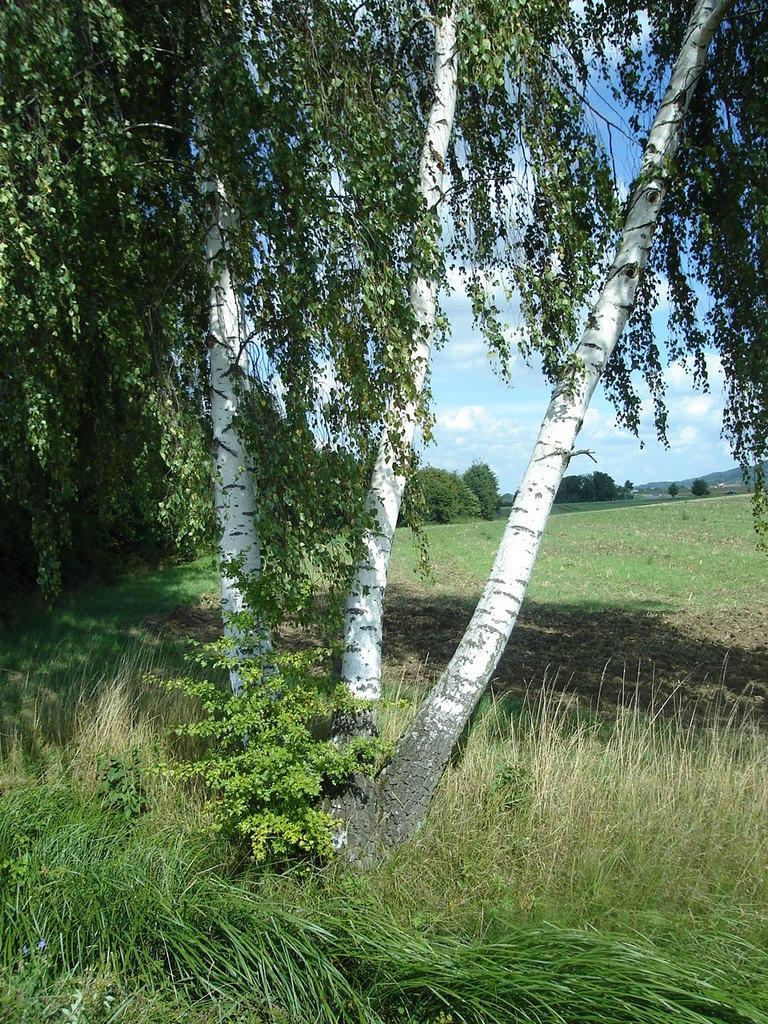What type of vegetation can be seen in the image? There are trees in the image. What is covering the bottom side and surrounding places in the image? The bottom side and surrounding places are covered with grass. What can be seen in the sky in the image? Clouds are visible in the sky. What is the taste of the grass in the image? The taste of the grass cannot be determined from the image, as taste is not a visual characteristic. 